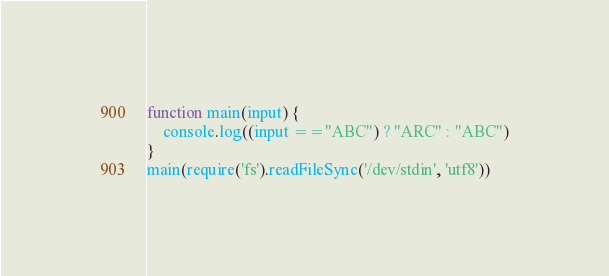<code> <loc_0><loc_0><loc_500><loc_500><_JavaScript_>function main(input) {
    console.log((input =="ABC") ? "ARC" : "ABC")
}
main(require('fs').readFileSync('/dev/stdin', 'utf8'))</code> 